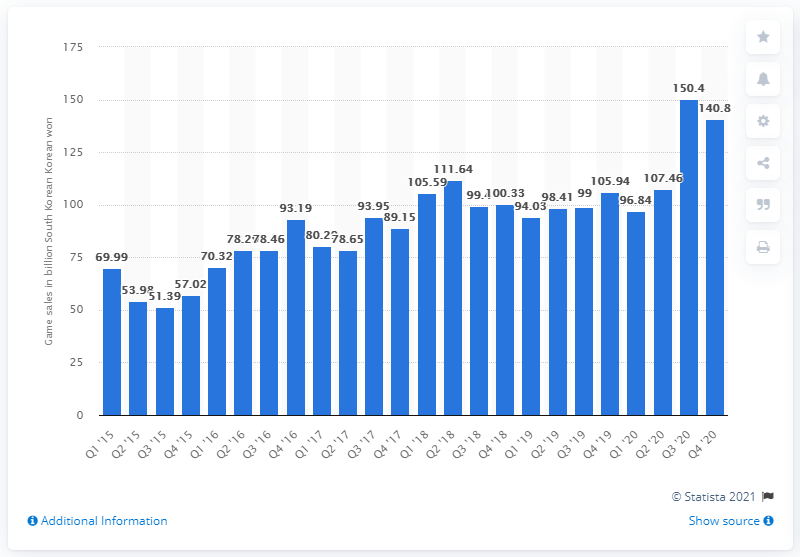Give some essential details in this illustration. In the fourth quarter of 2020, Daum Kakao generated a total of 140.8 billion South Korean won in revenue. 